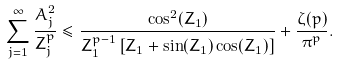<formula> <loc_0><loc_0><loc_500><loc_500>\sum _ { j = 1 } ^ { \infty } \frac { A _ { j } ^ { 2 } } { Z _ { j } ^ { p } } \leq \frac { \cos ^ { 2 } ( Z _ { 1 } ) } { Z _ { 1 } ^ { p - 1 } \left [ Z _ { 1 } + \sin ( Z _ { 1 } ) \cos ( Z _ { 1 } ) \right ] } + \frac { \zeta ( p ) } { \pi ^ { p } } .</formula> 